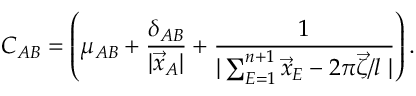Convert formula to latex. <formula><loc_0><loc_0><loc_500><loc_500>C _ { A B } = \left ( \mu _ { A B } + \frac { \delta _ { A B } } { | \vec { x } _ { A } | } + \frac { 1 } { | \sum _ { E = 1 } ^ { n + 1 } \vec { x } _ { E } - 2 \pi \vec { \zeta } / l \, | } \right ) .</formula> 